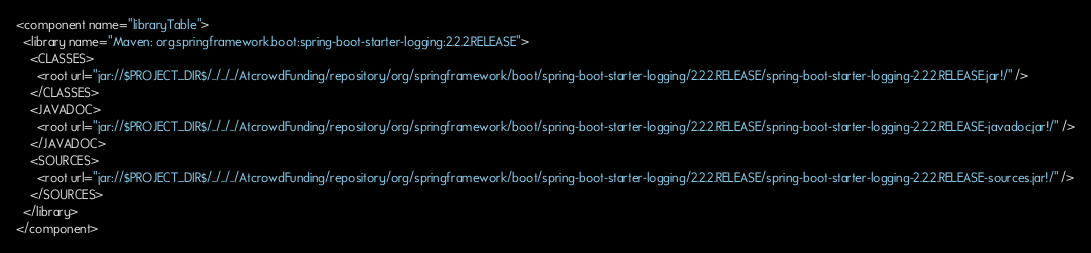Convert code to text. <code><loc_0><loc_0><loc_500><loc_500><_XML_><component name="libraryTable">
  <library name="Maven: org.springframework.boot:spring-boot-starter-logging:2.2.2.RELEASE">
    <CLASSES>
      <root url="jar://$PROJECT_DIR$/../../../AtcrowdFunding/repository/org/springframework/boot/spring-boot-starter-logging/2.2.2.RELEASE/spring-boot-starter-logging-2.2.2.RELEASE.jar!/" />
    </CLASSES>
    <JAVADOC>
      <root url="jar://$PROJECT_DIR$/../../../AtcrowdFunding/repository/org/springframework/boot/spring-boot-starter-logging/2.2.2.RELEASE/spring-boot-starter-logging-2.2.2.RELEASE-javadoc.jar!/" />
    </JAVADOC>
    <SOURCES>
      <root url="jar://$PROJECT_DIR$/../../../AtcrowdFunding/repository/org/springframework/boot/spring-boot-starter-logging/2.2.2.RELEASE/spring-boot-starter-logging-2.2.2.RELEASE-sources.jar!/" />
    </SOURCES>
  </library>
</component></code> 